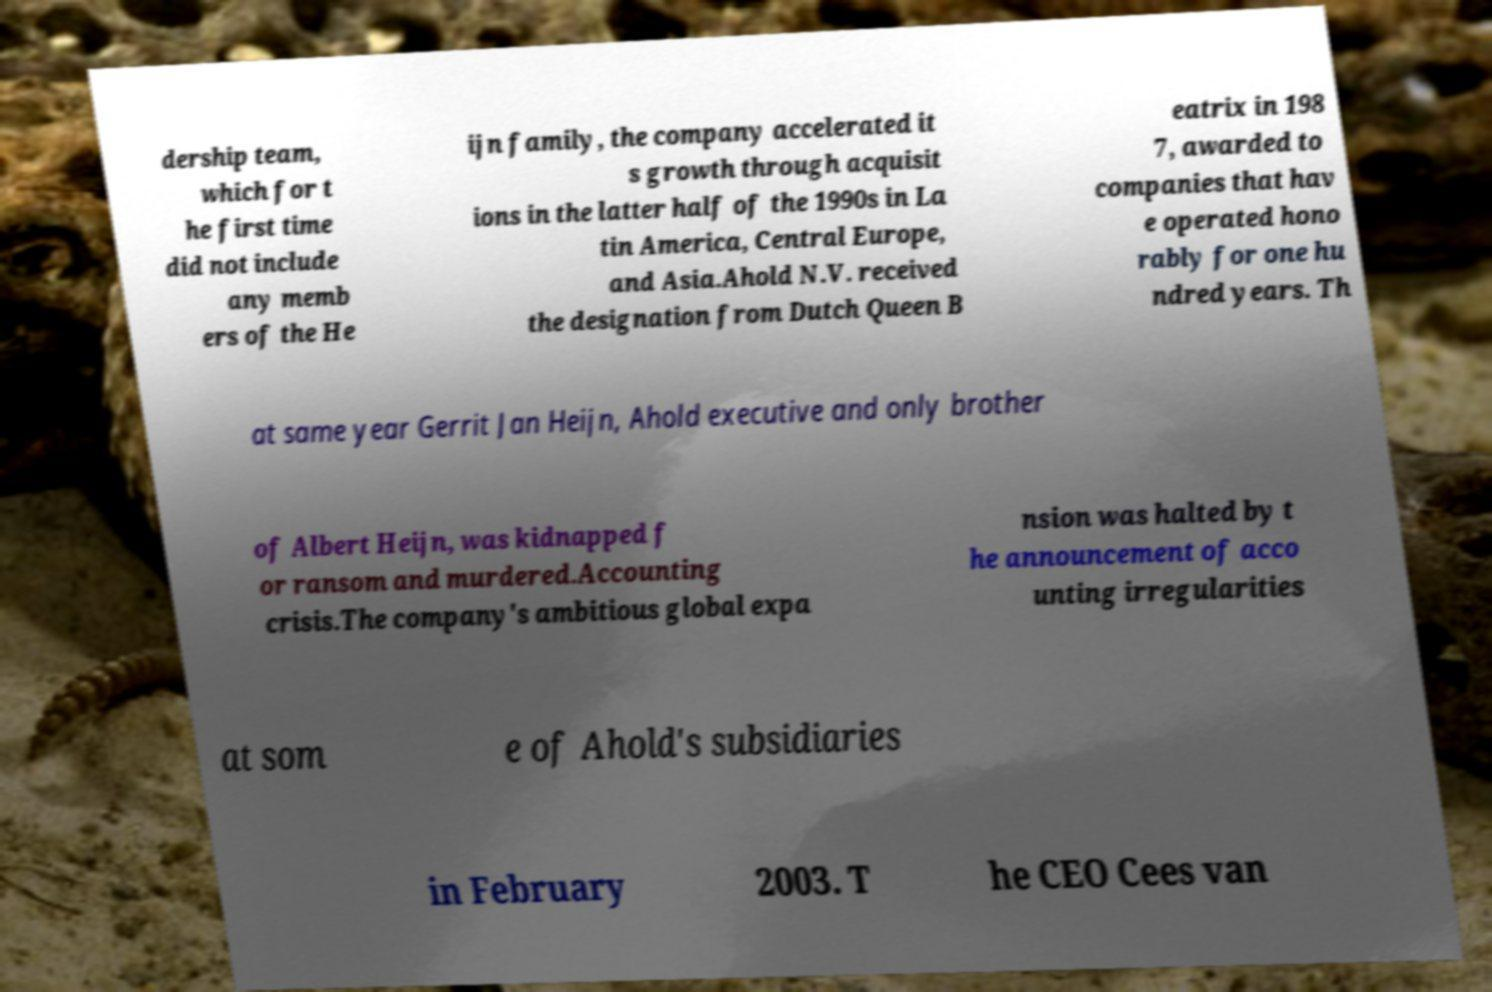Could you assist in decoding the text presented in this image and type it out clearly? dership team, which for t he first time did not include any memb ers of the He ijn family, the company accelerated it s growth through acquisit ions in the latter half of the 1990s in La tin America, Central Europe, and Asia.Ahold N.V. received the designation from Dutch Queen B eatrix in 198 7, awarded to companies that hav e operated hono rably for one hu ndred years. Th at same year Gerrit Jan Heijn, Ahold executive and only brother of Albert Heijn, was kidnapped f or ransom and murdered.Accounting crisis.The company's ambitious global expa nsion was halted by t he announcement of acco unting irregularities at som e of Ahold's subsidiaries in February 2003. T he CEO Cees van 